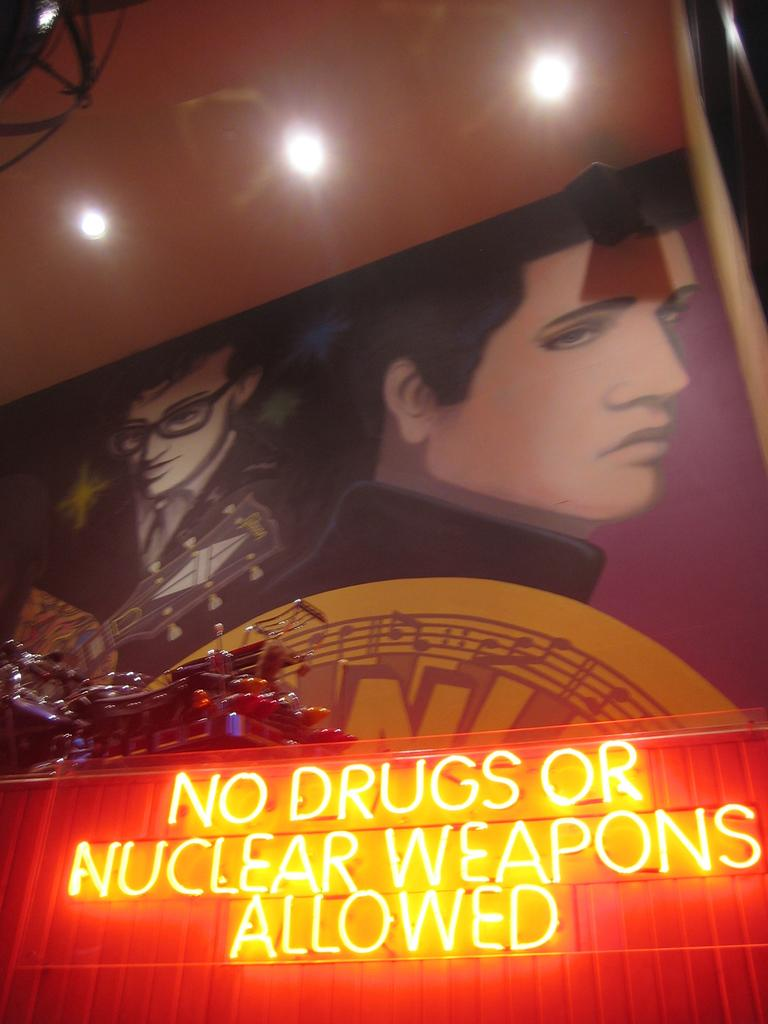Provide a one-sentence caption for the provided image. Art with a sign below it that read no drugs or nuclear weapons allowed. 